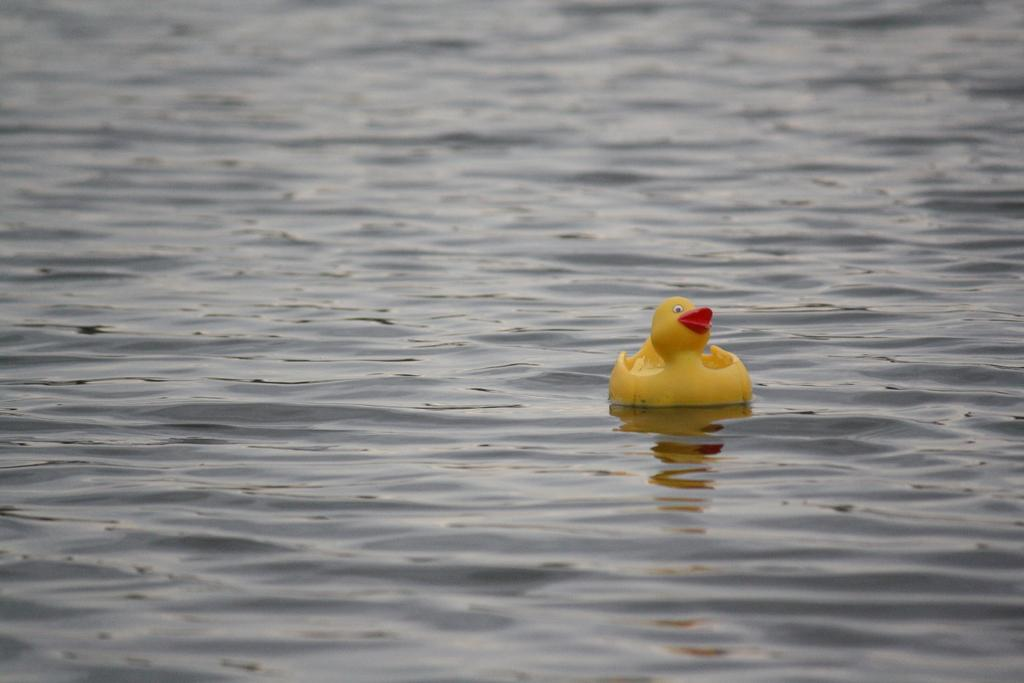What object is floating on the water in the image? There is a toy in the image, and it is on the surface of the water. What can be observed about the water in the image? The water has ripples. What type of worm can be seen crawling on the toy in the image? There is no worm present in the image; it only features a toy floating on the water with ripples. 